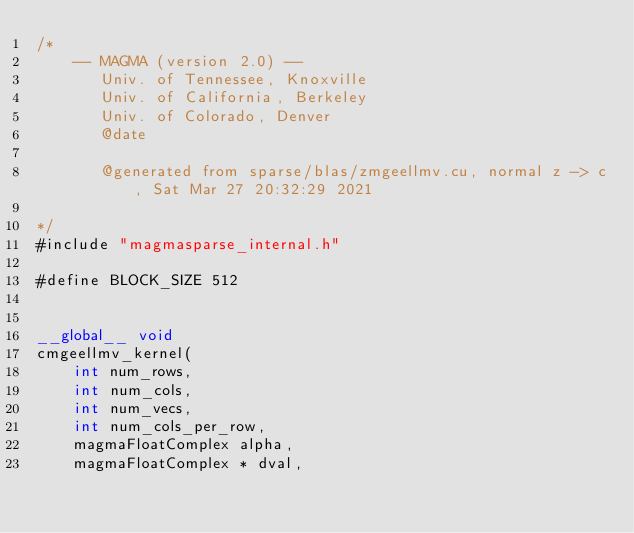Convert code to text. <code><loc_0><loc_0><loc_500><loc_500><_Cuda_>/*
    -- MAGMA (version 2.0) --
       Univ. of Tennessee, Knoxville
       Univ. of California, Berkeley
       Univ. of Colorado, Denver
       @date

       @generated from sparse/blas/zmgeellmv.cu, normal z -> c, Sat Mar 27 20:32:29 2021

*/
#include "magmasparse_internal.h"

#define BLOCK_SIZE 512


__global__ void 
cmgeellmv_kernel( 
    int num_rows, 
    int num_cols,
    int num_vecs,
    int num_cols_per_row,
    magmaFloatComplex alpha, 
    magmaFloatComplex * dval, </code> 